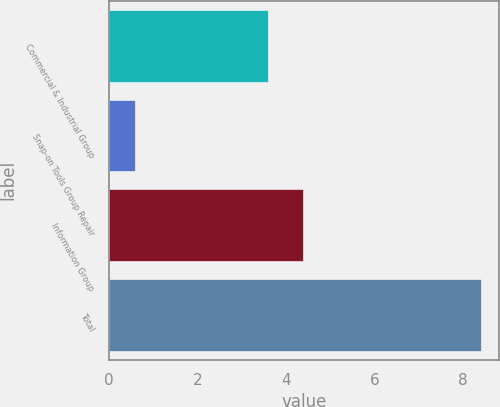Convert chart. <chart><loc_0><loc_0><loc_500><loc_500><bar_chart><fcel>Commercial & Industrial Group<fcel>Snap-on Tools Group Repair<fcel>Information Group<fcel>Total<nl><fcel>3.6<fcel>0.6<fcel>4.38<fcel>8.4<nl></chart> 